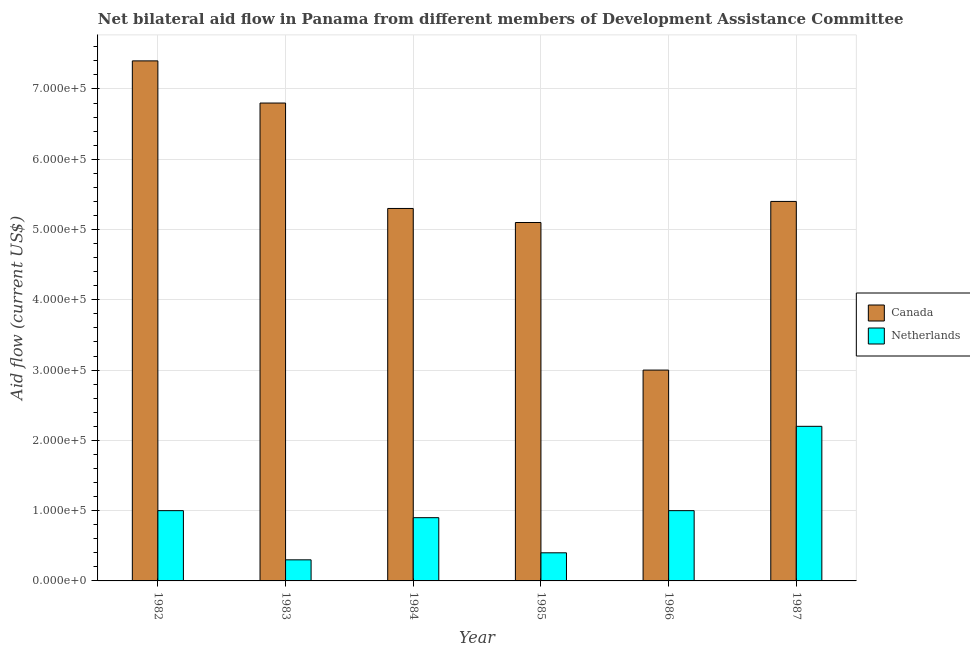How many different coloured bars are there?
Offer a very short reply. 2. How many groups of bars are there?
Your answer should be compact. 6. Are the number of bars per tick equal to the number of legend labels?
Make the answer very short. Yes. Are the number of bars on each tick of the X-axis equal?
Ensure brevity in your answer.  Yes. How many bars are there on the 1st tick from the left?
Your answer should be very brief. 2. What is the label of the 5th group of bars from the left?
Your answer should be very brief. 1986. In how many cases, is the number of bars for a given year not equal to the number of legend labels?
Your answer should be very brief. 0. What is the amount of aid given by netherlands in 1984?
Offer a terse response. 9.00e+04. Across all years, what is the maximum amount of aid given by canada?
Provide a short and direct response. 7.40e+05. Across all years, what is the minimum amount of aid given by canada?
Ensure brevity in your answer.  3.00e+05. What is the total amount of aid given by canada in the graph?
Provide a short and direct response. 3.30e+06. What is the difference between the amount of aid given by canada in 1983 and that in 1984?
Give a very brief answer. 1.50e+05. What is the difference between the amount of aid given by canada in 1982 and the amount of aid given by netherlands in 1985?
Offer a very short reply. 2.30e+05. What is the ratio of the amount of aid given by netherlands in 1986 to that in 1987?
Provide a succinct answer. 0.45. Is the difference between the amount of aid given by netherlands in 1983 and 1984 greater than the difference between the amount of aid given by canada in 1983 and 1984?
Provide a short and direct response. No. What is the difference between the highest and the second highest amount of aid given by netherlands?
Your answer should be very brief. 1.20e+05. What is the difference between the highest and the lowest amount of aid given by netherlands?
Provide a short and direct response. 1.90e+05. What does the 1st bar from the right in 1984 represents?
Offer a terse response. Netherlands. How many bars are there?
Keep it short and to the point. 12. Are all the bars in the graph horizontal?
Keep it short and to the point. No. Are the values on the major ticks of Y-axis written in scientific E-notation?
Offer a terse response. Yes. Does the graph contain grids?
Ensure brevity in your answer.  Yes. Where does the legend appear in the graph?
Ensure brevity in your answer.  Center right. How are the legend labels stacked?
Offer a very short reply. Vertical. What is the title of the graph?
Offer a terse response. Net bilateral aid flow in Panama from different members of Development Assistance Committee. What is the label or title of the X-axis?
Your response must be concise. Year. What is the label or title of the Y-axis?
Make the answer very short. Aid flow (current US$). What is the Aid flow (current US$) of Canada in 1982?
Keep it short and to the point. 7.40e+05. What is the Aid flow (current US$) in Netherlands in 1982?
Make the answer very short. 1.00e+05. What is the Aid flow (current US$) in Canada in 1983?
Keep it short and to the point. 6.80e+05. What is the Aid flow (current US$) in Netherlands in 1983?
Give a very brief answer. 3.00e+04. What is the Aid flow (current US$) of Canada in 1984?
Provide a short and direct response. 5.30e+05. What is the Aid flow (current US$) in Netherlands in 1984?
Make the answer very short. 9.00e+04. What is the Aid flow (current US$) in Canada in 1985?
Provide a succinct answer. 5.10e+05. What is the Aid flow (current US$) in Netherlands in 1985?
Provide a succinct answer. 4.00e+04. What is the Aid flow (current US$) of Canada in 1986?
Offer a terse response. 3.00e+05. What is the Aid flow (current US$) of Netherlands in 1986?
Provide a succinct answer. 1.00e+05. What is the Aid flow (current US$) of Canada in 1987?
Your answer should be compact. 5.40e+05. What is the Aid flow (current US$) in Netherlands in 1987?
Provide a succinct answer. 2.20e+05. Across all years, what is the maximum Aid flow (current US$) of Canada?
Provide a succinct answer. 7.40e+05. What is the total Aid flow (current US$) of Canada in the graph?
Keep it short and to the point. 3.30e+06. What is the total Aid flow (current US$) of Netherlands in the graph?
Keep it short and to the point. 5.80e+05. What is the difference between the Aid flow (current US$) in Netherlands in 1982 and that in 1983?
Provide a succinct answer. 7.00e+04. What is the difference between the Aid flow (current US$) of Canada in 1982 and that in 1984?
Ensure brevity in your answer.  2.10e+05. What is the difference between the Aid flow (current US$) of Netherlands in 1982 and that in 1984?
Ensure brevity in your answer.  10000. What is the difference between the Aid flow (current US$) in Netherlands in 1982 and that in 1985?
Offer a very short reply. 6.00e+04. What is the difference between the Aid flow (current US$) in Canada in 1982 and that in 1986?
Make the answer very short. 4.40e+05. What is the difference between the Aid flow (current US$) of Netherlands in 1982 and that in 1986?
Provide a short and direct response. 0. What is the difference between the Aid flow (current US$) of Canada in 1982 and that in 1987?
Keep it short and to the point. 2.00e+05. What is the difference between the Aid flow (current US$) of Netherlands in 1982 and that in 1987?
Offer a terse response. -1.20e+05. What is the difference between the Aid flow (current US$) of Netherlands in 1983 and that in 1985?
Provide a short and direct response. -10000. What is the difference between the Aid flow (current US$) in Canada in 1983 and that in 1987?
Offer a very short reply. 1.40e+05. What is the difference between the Aid flow (current US$) in Netherlands in 1983 and that in 1987?
Give a very brief answer. -1.90e+05. What is the difference between the Aid flow (current US$) in Netherlands in 1984 and that in 1985?
Your answer should be very brief. 5.00e+04. What is the difference between the Aid flow (current US$) in Netherlands in 1984 and that in 1986?
Offer a terse response. -10000. What is the difference between the Aid flow (current US$) of Canada in 1984 and that in 1987?
Your response must be concise. -10000. What is the difference between the Aid flow (current US$) of Netherlands in 1984 and that in 1987?
Your answer should be very brief. -1.30e+05. What is the difference between the Aid flow (current US$) in Canada in 1985 and that in 1986?
Give a very brief answer. 2.10e+05. What is the difference between the Aid flow (current US$) of Netherlands in 1985 and that in 1986?
Offer a very short reply. -6.00e+04. What is the difference between the Aid flow (current US$) in Netherlands in 1985 and that in 1987?
Your response must be concise. -1.80e+05. What is the difference between the Aid flow (current US$) in Netherlands in 1986 and that in 1987?
Offer a terse response. -1.20e+05. What is the difference between the Aid flow (current US$) in Canada in 1982 and the Aid flow (current US$) in Netherlands in 1983?
Make the answer very short. 7.10e+05. What is the difference between the Aid flow (current US$) of Canada in 1982 and the Aid flow (current US$) of Netherlands in 1984?
Your response must be concise. 6.50e+05. What is the difference between the Aid flow (current US$) of Canada in 1982 and the Aid flow (current US$) of Netherlands in 1986?
Provide a succinct answer. 6.40e+05. What is the difference between the Aid flow (current US$) in Canada in 1982 and the Aid flow (current US$) in Netherlands in 1987?
Your answer should be compact. 5.20e+05. What is the difference between the Aid flow (current US$) of Canada in 1983 and the Aid flow (current US$) of Netherlands in 1984?
Offer a very short reply. 5.90e+05. What is the difference between the Aid flow (current US$) of Canada in 1983 and the Aid flow (current US$) of Netherlands in 1985?
Offer a very short reply. 6.40e+05. What is the difference between the Aid flow (current US$) of Canada in 1983 and the Aid flow (current US$) of Netherlands in 1986?
Give a very brief answer. 5.80e+05. What is the difference between the Aid flow (current US$) in Canada in 1983 and the Aid flow (current US$) in Netherlands in 1987?
Your answer should be very brief. 4.60e+05. What is the difference between the Aid flow (current US$) of Canada in 1984 and the Aid flow (current US$) of Netherlands in 1986?
Provide a succinct answer. 4.30e+05. What is the difference between the Aid flow (current US$) in Canada in 1985 and the Aid flow (current US$) in Netherlands in 1986?
Offer a terse response. 4.10e+05. What is the difference between the Aid flow (current US$) of Canada in 1985 and the Aid flow (current US$) of Netherlands in 1987?
Ensure brevity in your answer.  2.90e+05. What is the difference between the Aid flow (current US$) in Canada in 1986 and the Aid flow (current US$) in Netherlands in 1987?
Offer a terse response. 8.00e+04. What is the average Aid flow (current US$) of Netherlands per year?
Your response must be concise. 9.67e+04. In the year 1982, what is the difference between the Aid flow (current US$) in Canada and Aid flow (current US$) in Netherlands?
Provide a short and direct response. 6.40e+05. In the year 1983, what is the difference between the Aid flow (current US$) in Canada and Aid flow (current US$) in Netherlands?
Make the answer very short. 6.50e+05. In the year 1985, what is the difference between the Aid flow (current US$) in Canada and Aid flow (current US$) in Netherlands?
Your answer should be compact. 4.70e+05. What is the ratio of the Aid flow (current US$) of Canada in 1982 to that in 1983?
Provide a succinct answer. 1.09. What is the ratio of the Aid flow (current US$) in Netherlands in 1982 to that in 1983?
Ensure brevity in your answer.  3.33. What is the ratio of the Aid flow (current US$) in Canada in 1982 to that in 1984?
Your answer should be compact. 1.4. What is the ratio of the Aid flow (current US$) in Canada in 1982 to that in 1985?
Your answer should be compact. 1.45. What is the ratio of the Aid flow (current US$) of Canada in 1982 to that in 1986?
Your response must be concise. 2.47. What is the ratio of the Aid flow (current US$) of Canada in 1982 to that in 1987?
Give a very brief answer. 1.37. What is the ratio of the Aid flow (current US$) in Netherlands in 1982 to that in 1987?
Ensure brevity in your answer.  0.45. What is the ratio of the Aid flow (current US$) in Canada in 1983 to that in 1984?
Ensure brevity in your answer.  1.28. What is the ratio of the Aid flow (current US$) of Netherlands in 1983 to that in 1985?
Keep it short and to the point. 0.75. What is the ratio of the Aid flow (current US$) in Canada in 1983 to that in 1986?
Offer a very short reply. 2.27. What is the ratio of the Aid flow (current US$) of Canada in 1983 to that in 1987?
Your response must be concise. 1.26. What is the ratio of the Aid flow (current US$) in Netherlands in 1983 to that in 1987?
Your answer should be compact. 0.14. What is the ratio of the Aid flow (current US$) in Canada in 1984 to that in 1985?
Keep it short and to the point. 1.04. What is the ratio of the Aid flow (current US$) of Netherlands in 1984 to that in 1985?
Your answer should be compact. 2.25. What is the ratio of the Aid flow (current US$) of Canada in 1984 to that in 1986?
Your answer should be compact. 1.77. What is the ratio of the Aid flow (current US$) in Netherlands in 1984 to that in 1986?
Offer a very short reply. 0.9. What is the ratio of the Aid flow (current US$) of Canada in 1984 to that in 1987?
Your answer should be very brief. 0.98. What is the ratio of the Aid flow (current US$) of Netherlands in 1984 to that in 1987?
Keep it short and to the point. 0.41. What is the ratio of the Aid flow (current US$) of Canada in 1985 to that in 1986?
Make the answer very short. 1.7. What is the ratio of the Aid flow (current US$) in Netherlands in 1985 to that in 1986?
Ensure brevity in your answer.  0.4. What is the ratio of the Aid flow (current US$) of Netherlands in 1985 to that in 1987?
Your response must be concise. 0.18. What is the ratio of the Aid flow (current US$) of Canada in 1986 to that in 1987?
Offer a terse response. 0.56. What is the ratio of the Aid flow (current US$) of Netherlands in 1986 to that in 1987?
Your answer should be compact. 0.45. 